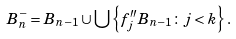Convert formula to latex. <formula><loc_0><loc_0><loc_500><loc_500>B ^ { - } _ { n } = B _ { n - 1 } \cup \bigcup \left \{ f _ { j } ^ { \prime \prime } B _ { n - 1 } \colon j < k \right \} .</formula> 